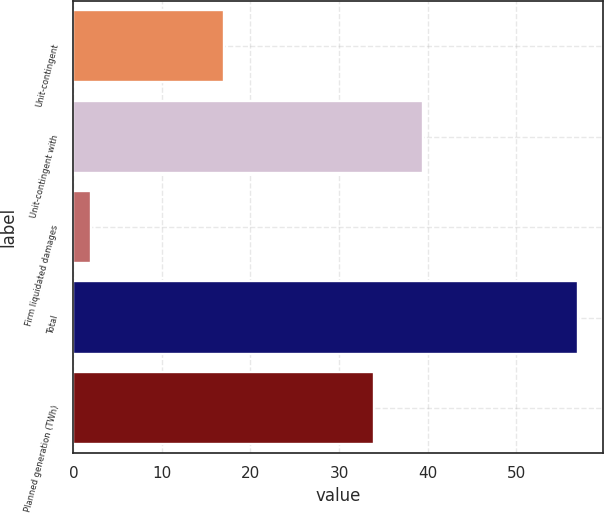Convert chart. <chart><loc_0><loc_0><loc_500><loc_500><bar_chart><fcel>Unit-contingent<fcel>Unit-contingent with<fcel>Firm liquidated damages<fcel>Total<fcel>Planned generation (TWh)<nl><fcel>17<fcel>39.5<fcel>2<fcel>57<fcel>34<nl></chart> 